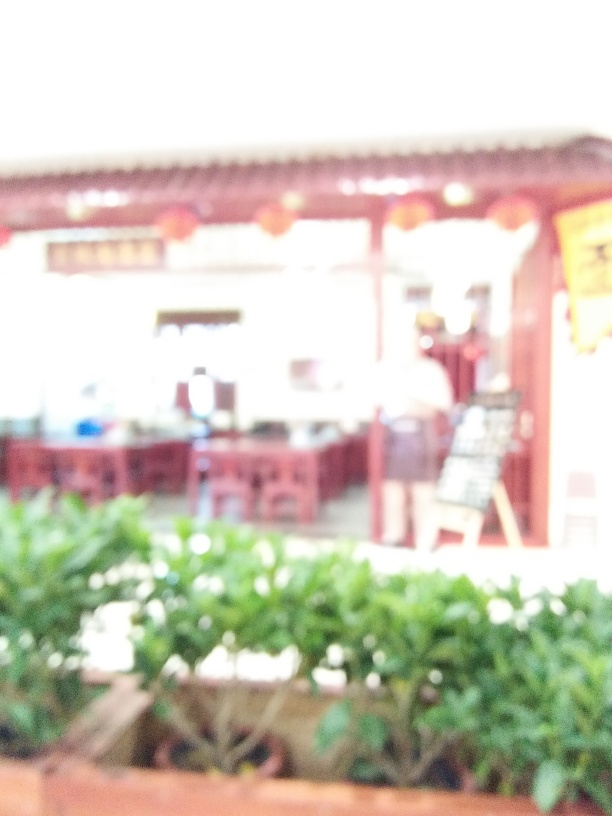Can you tell if this place is indoors or outdoors? Despite the blur, we can determine that the setting is outdoors. There is natural lighting present, and the brightness suggests an open environment possibly during daytime. 